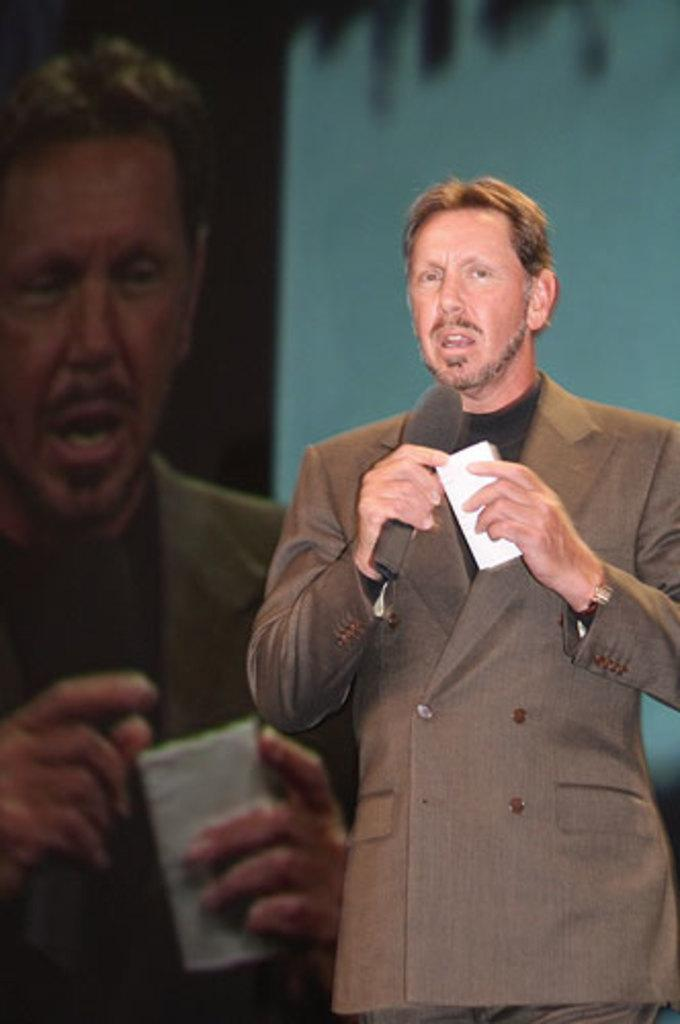What is the man doing on the right side of the image? The man is standing on the right side of the image and holding a mic. What else is the man holding in the image? The man is also holding a paper in the image. What can be seen in the background of the image? There is a screen in the background of the image. What type of shoe is the yak wearing in the image? There is no yak present in the image, and therefore no shoes to describe. 